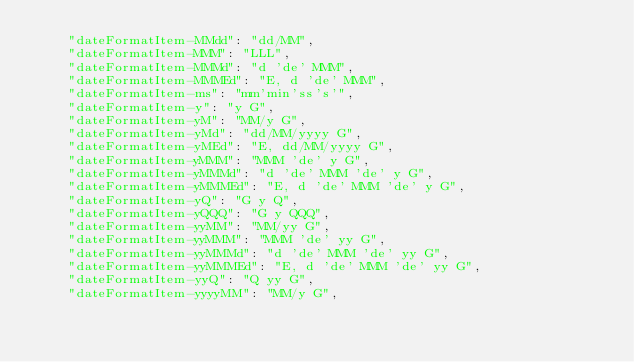<code> <loc_0><loc_0><loc_500><loc_500><_JavaScript_>	"dateFormatItem-MMdd": "dd/MM",
	"dateFormatItem-MMM": "LLL",
	"dateFormatItem-MMMd": "d 'de' MMM",
	"dateFormatItem-MMMEd": "E, d 'de' MMM",
	"dateFormatItem-ms": "mm'min'ss's'",
	"dateFormatItem-y": "y G",
	"dateFormatItem-yM": "MM/y G",
	"dateFormatItem-yMd": "dd/MM/yyyy G",
	"dateFormatItem-yMEd": "E, dd/MM/yyyy G",
	"dateFormatItem-yMMM": "MMM 'de' y G",
	"dateFormatItem-yMMMd": "d 'de' MMM 'de' y G",
	"dateFormatItem-yMMMEd": "E, d 'de' MMM 'de' y G",
	"dateFormatItem-yQ": "G y Q",
	"dateFormatItem-yQQQ": "G y QQQ",
	"dateFormatItem-yyMM": "MM/yy G",
	"dateFormatItem-yyMMM": "MMM 'de' yy G",
	"dateFormatItem-yyMMMd": "d 'de' MMM 'de' yy G",
	"dateFormatItem-yyMMMEd": "E, d 'de' MMM 'de' yy G",
	"dateFormatItem-yyQ": "Q yy G",
	"dateFormatItem-yyyyMM": "MM/y G",</code> 